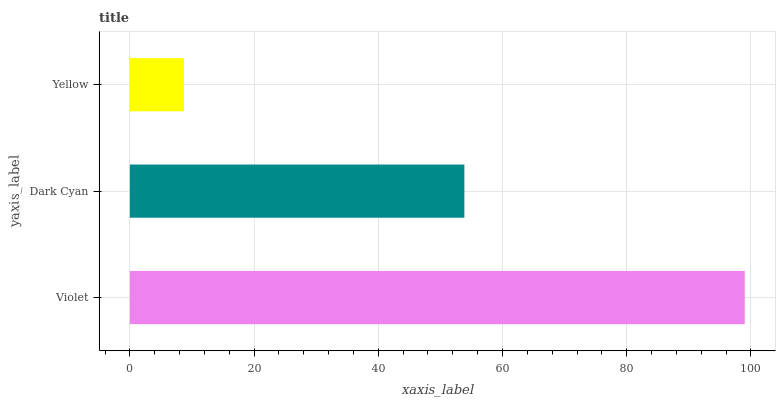Is Yellow the minimum?
Answer yes or no. Yes. Is Violet the maximum?
Answer yes or no. Yes. Is Dark Cyan the minimum?
Answer yes or no. No. Is Dark Cyan the maximum?
Answer yes or no. No. Is Violet greater than Dark Cyan?
Answer yes or no. Yes. Is Dark Cyan less than Violet?
Answer yes or no. Yes. Is Dark Cyan greater than Violet?
Answer yes or no. No. Is Violet less than Dark Cyan?
Answer yes or no. No. Is Dark Cyan the high median?
Answer yes or no. Yes. Is Dark Cyan the low median?
Answer yes or no. Yes. Is Violet the high median?
Answer yes or no. No. Is Yellow the low median?
Answer yes or no. No. 